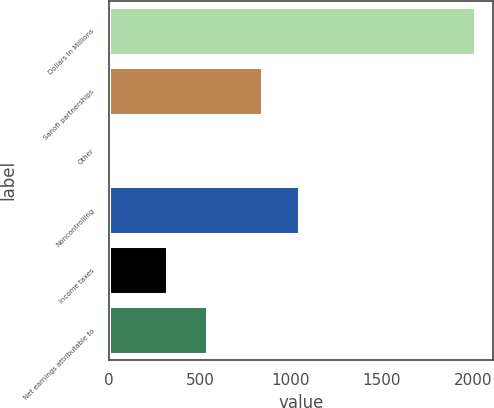Convert chart to OTSL. <chart><loc_0><loc_0><loc_500><loc_500><bar_chart><fcel>Dollars in Millions<fcel>Sanofi partnerships<fcel>Other<fcel>Noncontrolling<fcel>Income taxes<fcel>Net earnings attributable to<nl><fcel>2012<fcel>844<fcel>14<fcel>1043.8<fcel>317<fcel>541<nl></chart> 